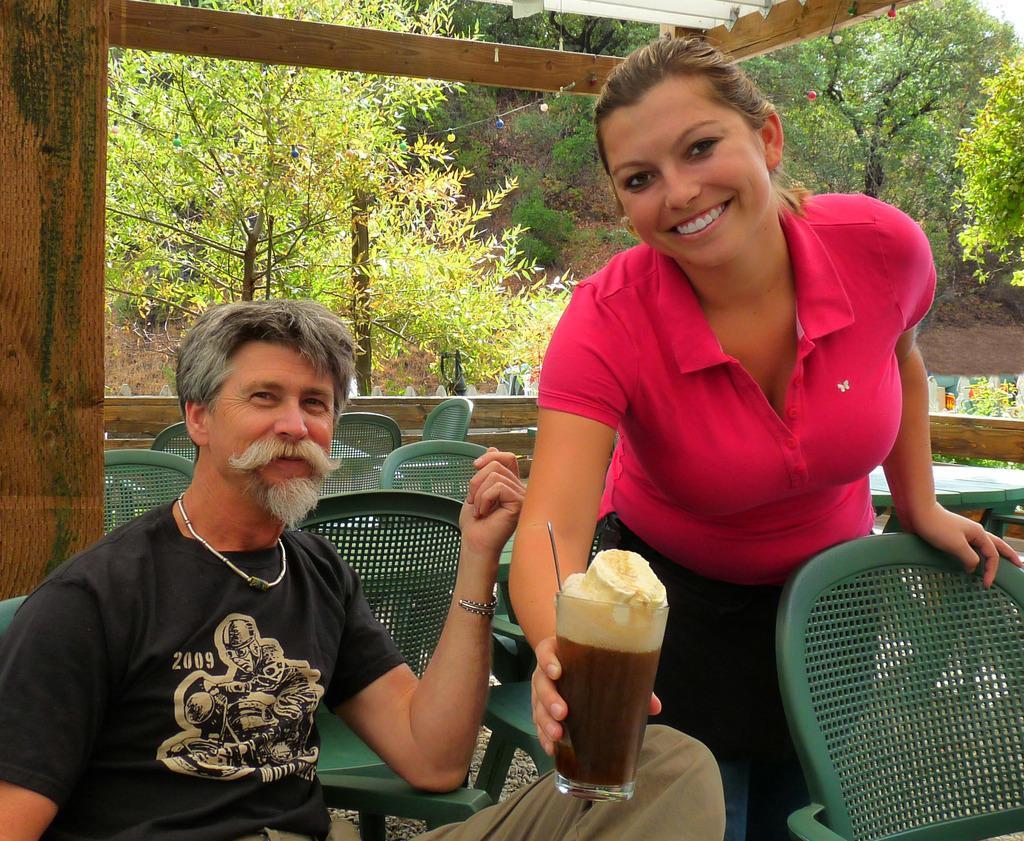Please provide a concise description of this image. In the image we can see there is a man sitting on chair and a woman is standing and holding juice glass in her hand. Behind there are tables, chairs and there are lot of trees. 